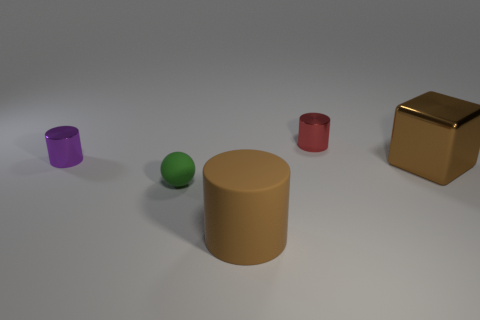Add 1 large cylinders. How many objects exist? 6 Subtract all spheres. How many objects are left? 4 Add 4 tiny red metallic things. How many tiny red metallic things are left? 5 Add 1 metallic blocks. How many metallic blocks exist? 2 Subtract 0 gray spheres. How many objects are left? 5 Subtract all rubber things. Subtract all large metal cubes. How many objects are left? 2 